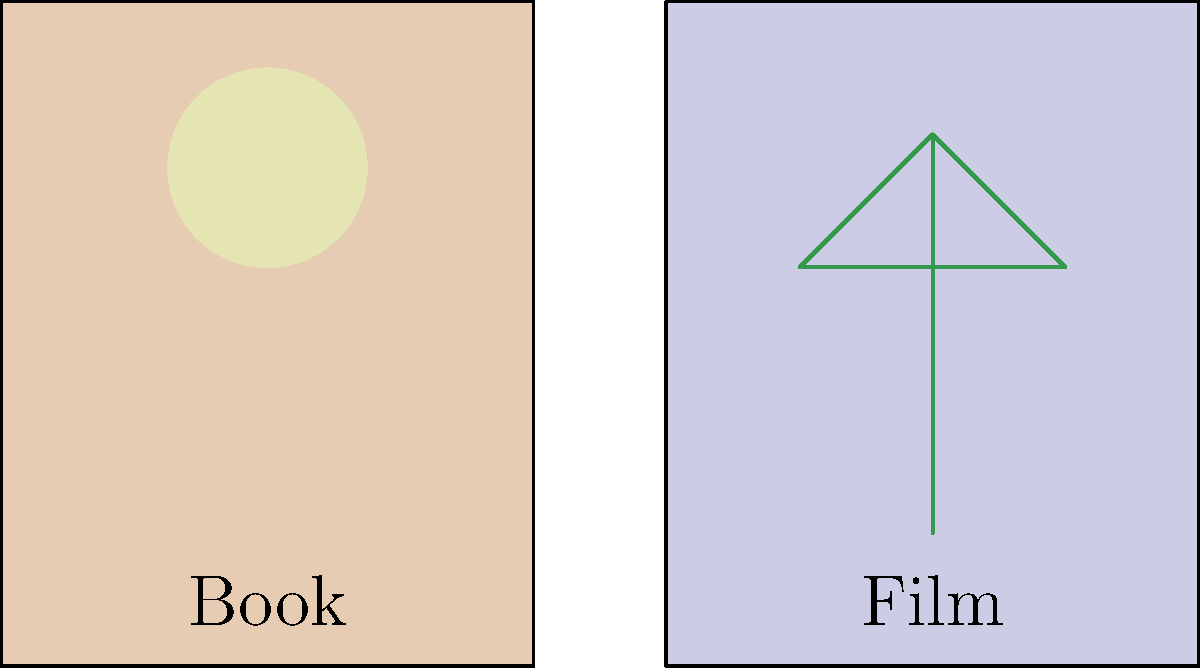Analyze the visual symbolism in the provided movie poster and book cover. How do the symbols differ, and what might this suggest about the adaptation process from literature to film? 1. Book cover symbol:
   - A full moon is depicted on the book cover.
   - The moon often symbolizes mystery, cycles, or transformation in literature.

2. Movie poster symbol:
   - A stylized tree is shown on the movie poster.
   - Trees typically represent growth, strength, or interconnectedness in visual media.

3. Color schemes:
   - The book cover has a warmer, sepia-toned background.
   - The movie poster features a cooler, bluish background.

4. Symbolism comparison:
   - The moon (book) suggests a focus on internal, emotional, or psychological elements.
   - The tree (film) implies a more external, tangible, or action-oriented approach.

5. Adaptation process implications:
   - The shift from moon to tree symbolism may indicate a change in narrative focus.
   - The film adaptation might emphasize more visible, concrete elements of the story.
   - This could suggest a transformation of abstract literary themes into more visually striking cinematic elements.

6. Artistic interpretation:
   - The differing symbols demonstrate how visual artists (book cover designer and movie poster artist) interpreted the core themes of the story.
   - This variation highlights the creative process involved in adapting literature to film.
Answer: The symbols shift from internal (moon) to external (tree), suggesting the film adaptation emphasizes more tangible, visually striking elements of the story. 